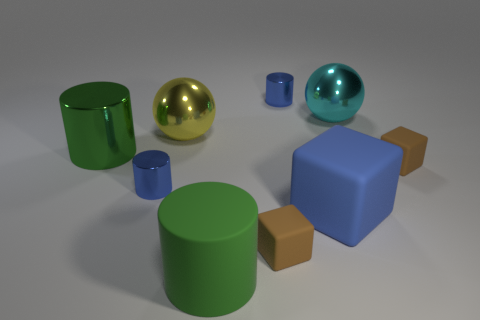Subtract all green cylinders. How many cylinders are left? 2 Subtract all small brown blocks. How many blocks are left? 1 Add 1 big cyan balls. How many objects exist? 10 Subtract all cubes. How many objects are left? 6 Add 1 yellow shiny balls. How many yellow shiny balls are left? 2 Add 4 big objects. How many big objects exist? 9 Subtract 0 green spheres. How many objects are left? 9 Subtract 4 cylinders. How many cylinders are left? 0 Subtract all cyan cylinders. Subtract all yellow spheres. How many cylinders are left? 4 Subtract all green balls. How many yellow blocks are left? 0 